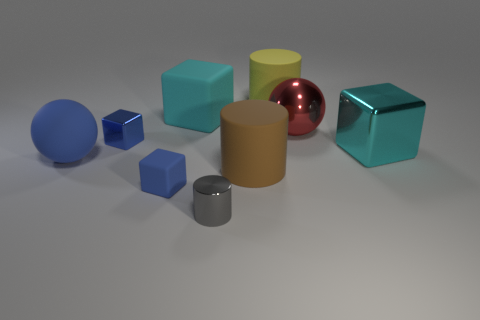Are there more brown rubber cylinders behind the tiny shiny cylinder than brown cylinders that are in front of the yellow rubber object?
Keep it short and to the point. No. Is the brown thing made of the same material as the red object?
Offer a terse response. No. How many rubber cubes are behind the big cylinder that is behind the big brown object?
Offer a terse response. 0. Do the matte cube behind the large brown rubber cylinder and the large metallic ball have the same color?
Your answer should be very brief. No. What number of things are either large spheres or things that are in front of the big yellow matte cylinder?
Keep it short and to the point. 8. Do the cyan object that is on the right side of the gray metallic cylinder and the small metallic thing that is behind the small gray thing have the same shape?
Ensure brevity in your answer.  Yes. Is there any other thing that has the same color as the tiny metallic cylinder?
Ensure brevity in your answer.  No. The blue object that is the same material as the gray thing is what shape?
Keep it short and to the point. Cube. There is a tiny thing that is behind the small gray shiny cylinder and in front of the large brown cylinder; what is its material?
Provide a succinct answer. Rubber. Do the large shiny cube and the large rubber block have the same color?
Provide a short and direct response. Yes. 